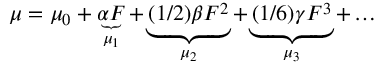<formula> <loc_0><loc_0><loc_500><loc_500>\mu = \mu _ { 0 } + \underbrace { \alpha F } _ { \mu _ { 1 } } + \underbrace { ( 1 / 2 ) \beta F ^ { 2 } } _ { \mu _ { 2 } } + \underbrace { ( 1 / 6 ) \gamma F ^ { 3 } } _ { \mu _ { 3 } } + \dots</formula> 